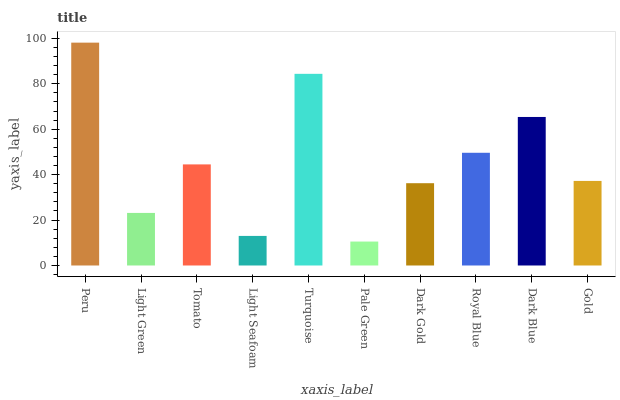Is Pale Green the minimum?
Answer yes or no. Yes. Is Peru the maximum?
Answer yes or no. Yes. Is Light Green the minimum?
Answer yes or no. No. Is Light Green the maximum?
Answer yes or no. No. Is Peru greater than Light Green?
Answer yes or no. Yes. Is Light Green less than Peru?
Answer yes or no. Yes. Is Light Green greater than Peru?
Answer yes or no. No. Is Peru less than Light Green?
Answer yes or no. No. Is Tomato the high median?
Answer yes or no. Yes. Is Gold the low median?
Answer yes or no. Yes. Is Light Green the high median?
Answer yes or no. No. Is Dark Blue the low median?
Answer yes or no. No. 